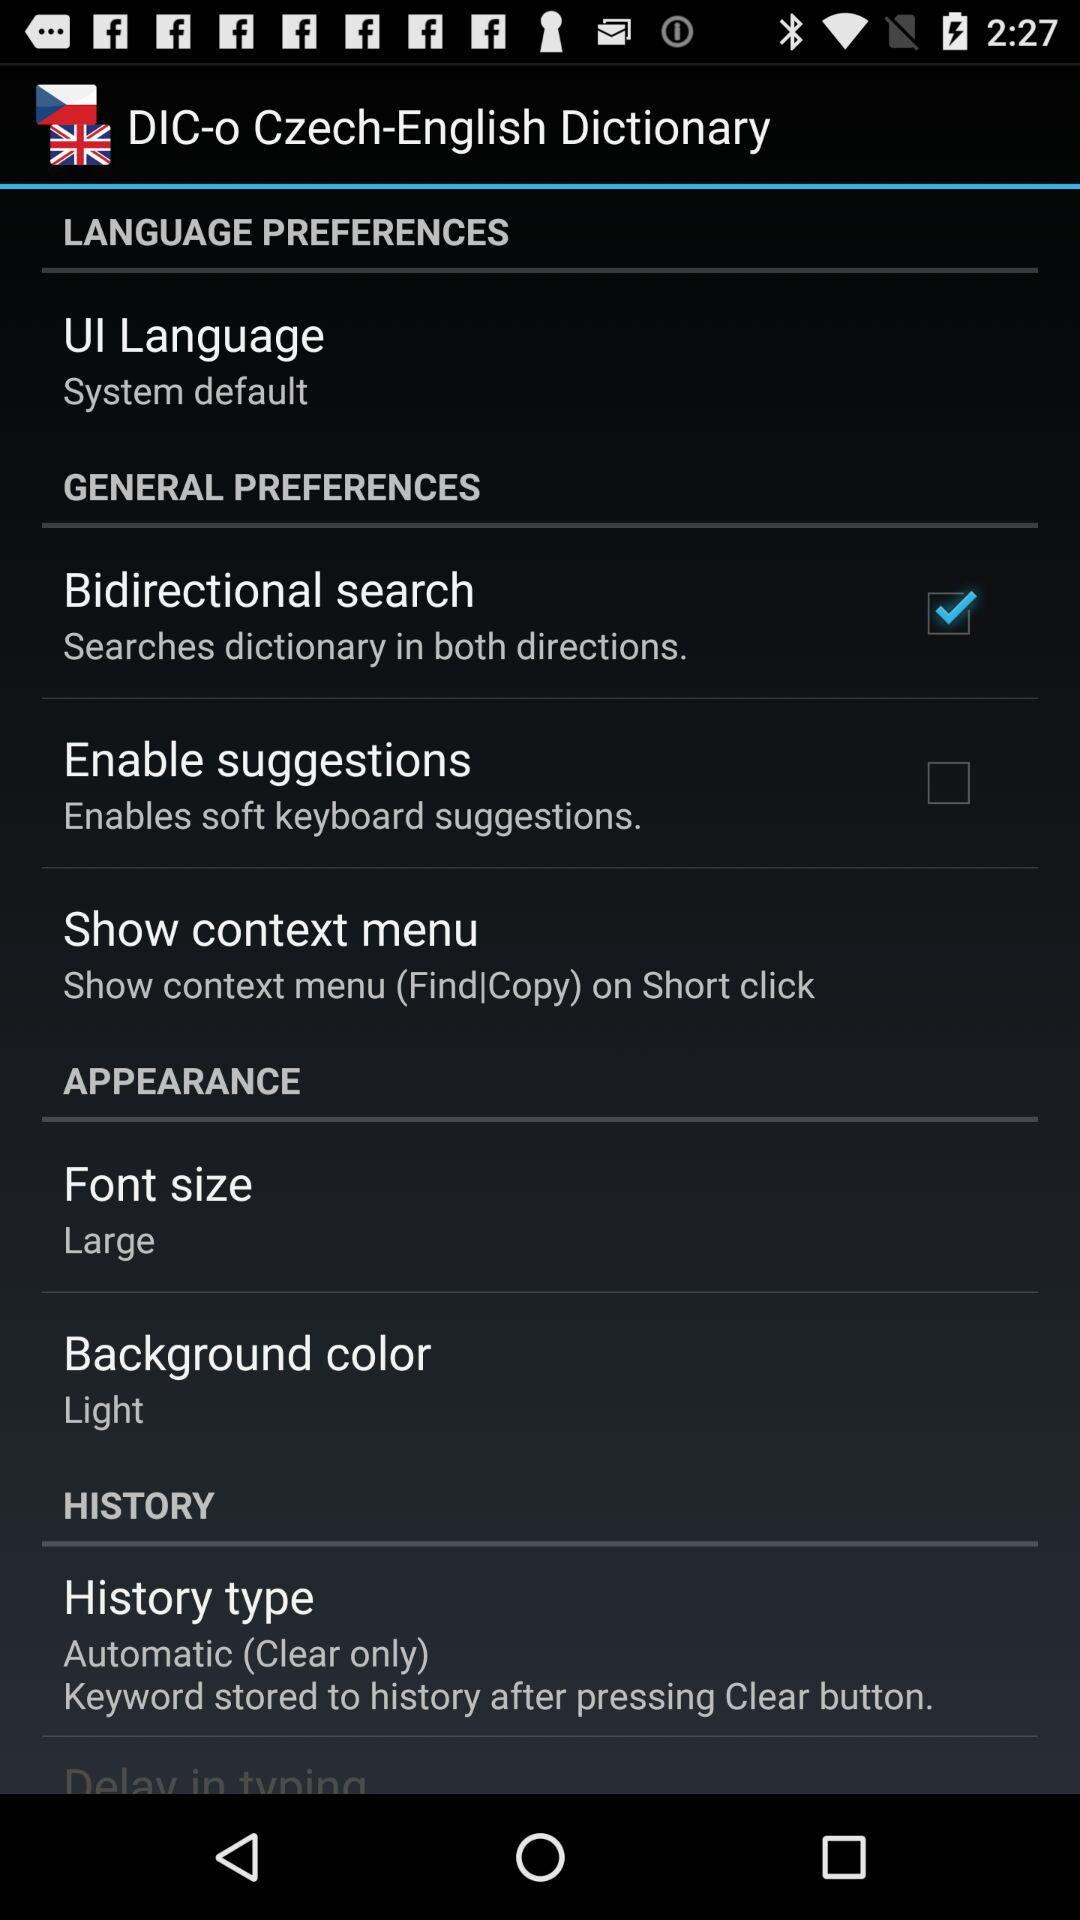How many check boxes are there in the whole screen?
Answer the question using a single word or phrase. 2 